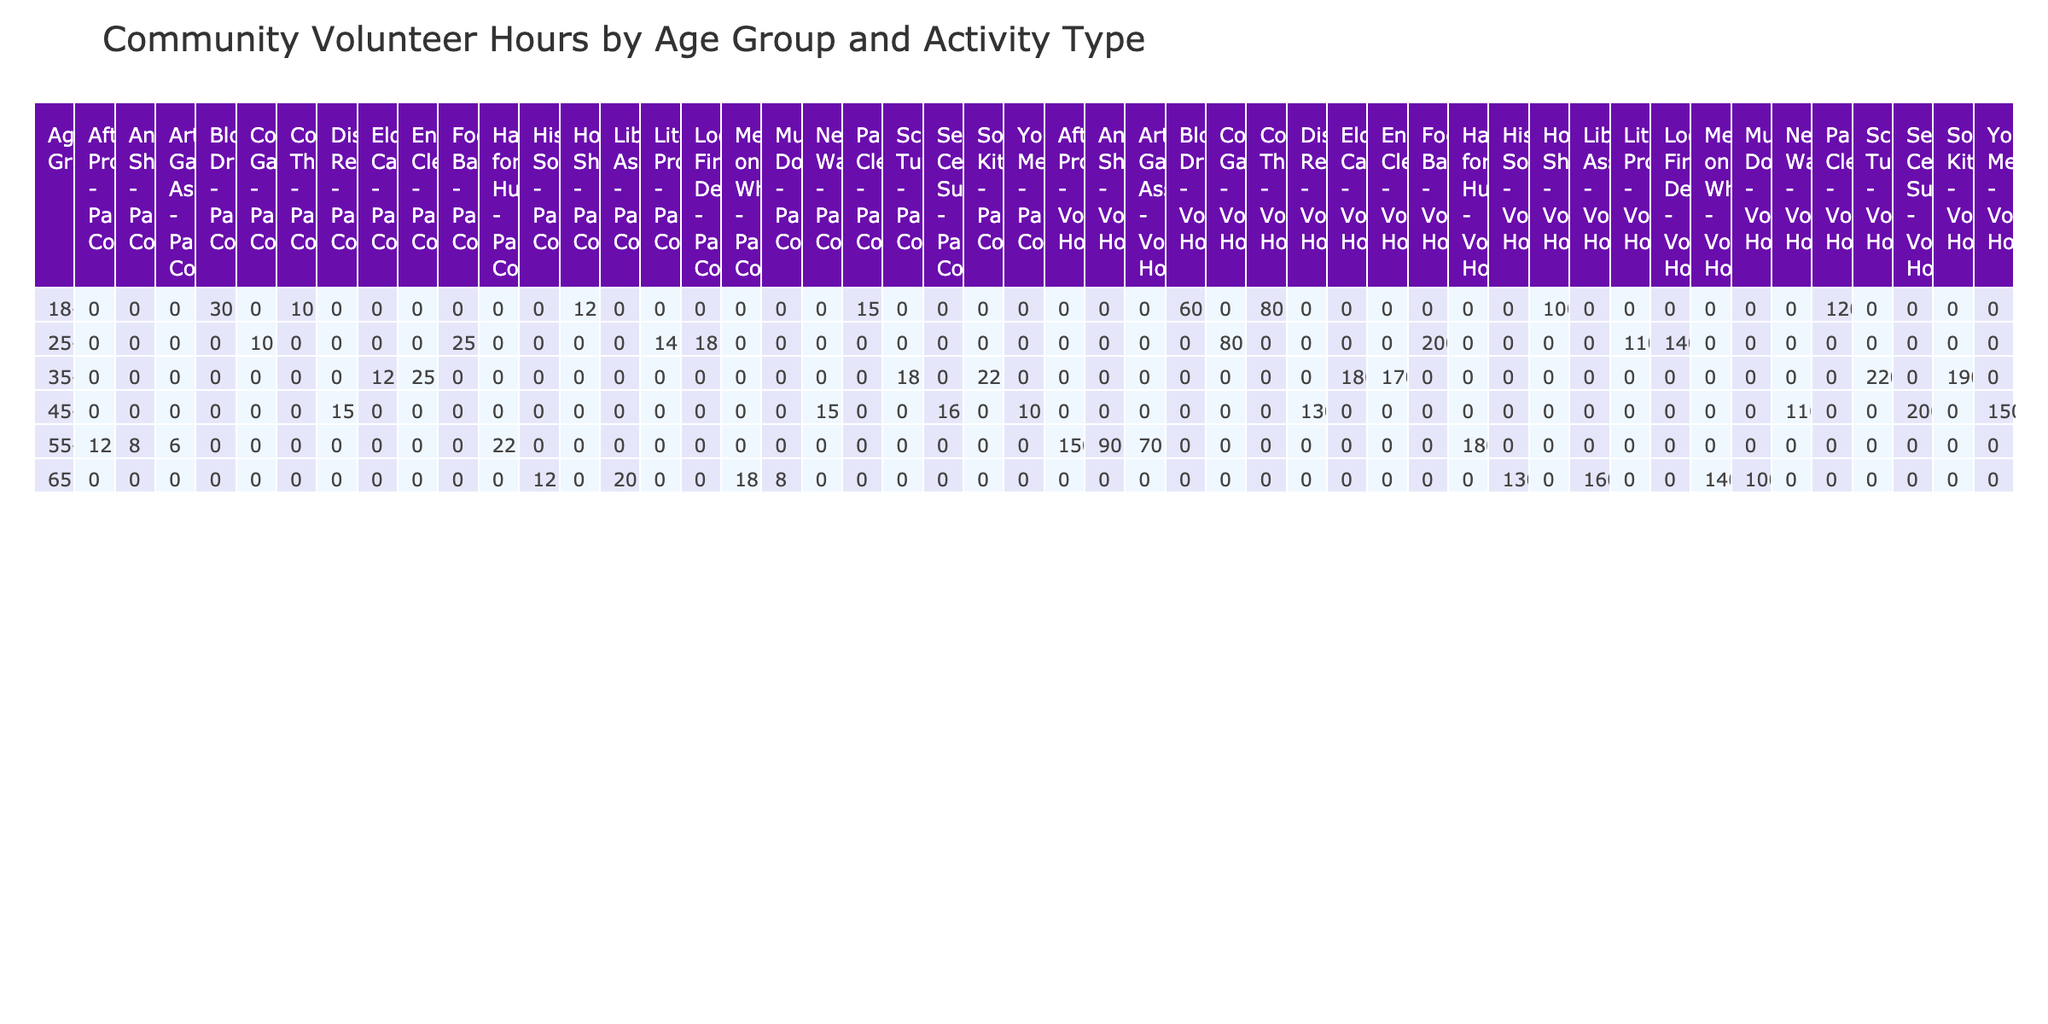What age group has the highest total volunteer hours? To find the age group with the highest total volunteer hours, I can sum the volunteer hours for each age group across all activity types. After calculating, I see that the 35-44 age group has the highest total at 1,200 hours.
Answer: 35-44 Which activity type received the least number of volunteer hours from any age group? I can check each activity type and compare the total hours. The activity type with the least hours is 'Art Gallery Assistance' with 70 hours by the 55-64 age group.
Answer: Art Gallery Assistance Did any age group under the age of 34 participate in 'Youth Mentoring'? Looking at the table, I see that 'Youth Mentoring' is only listed under the 45-54 age group, so no participants under 34 were involved in this activity.
Answer: No How many total volunteer hours were contributed by the 65+ age group? To find the total hours for the 65+ age group, I sum the hours from the relevant activities: Library Assistance (160) + Meals on Wheels (140) + Museum Docent (100) + Historical Society (130) = 630 hours.
Answer: 630 What is the average number of participant counts for 'Food Bank' and 'Community Garden'? First, I find the participant counts: 'Food Bank' has 25 participants and 'Community Garden' has 10 participants. The total is 25 + 10 = 35, and there are 2 activities. The average is 35/2, which equals 17.5.
Answer: 17.5 Which activity type had the highest participant count in the 55-64 age group? I can look at the participant counts for the 55-64 age group across different activities. The participant count for 'Habitat for Humanity' is 22, which is the highest for this age group.
Answer: Habitat for Humanity Is there an activity that received more than 200 volunteer hours from participants aged 25-34? Reviewing the table, the highest number of volunteer hours for the 25-34 age group is 200 for 'Food Bank', but there are no activities with more than 200 hours.
Answer: No What is the total difference in volunteer hours between the 18-24 and the 45-54 age groups? For the 18-24 age group, the total volunteer hours sum to 460 (120 + 100 + 60 + 80), and for the 45-54 age group, the total is 590 (150 + 130 + 200 + 110). The difference is 590 - 460 = 130 hours.
Answer: 130 What percentage of total volunteer hours comes from 'Park Cleanup' in comparison to the overall sum? The total volunteer hours across all activities is 2,785. 'Park Cleanup' has 120 hours. To find the percentage, I calculate (120/2785) * 100, which is approximately 4.3%.
Answer: 4.3% 